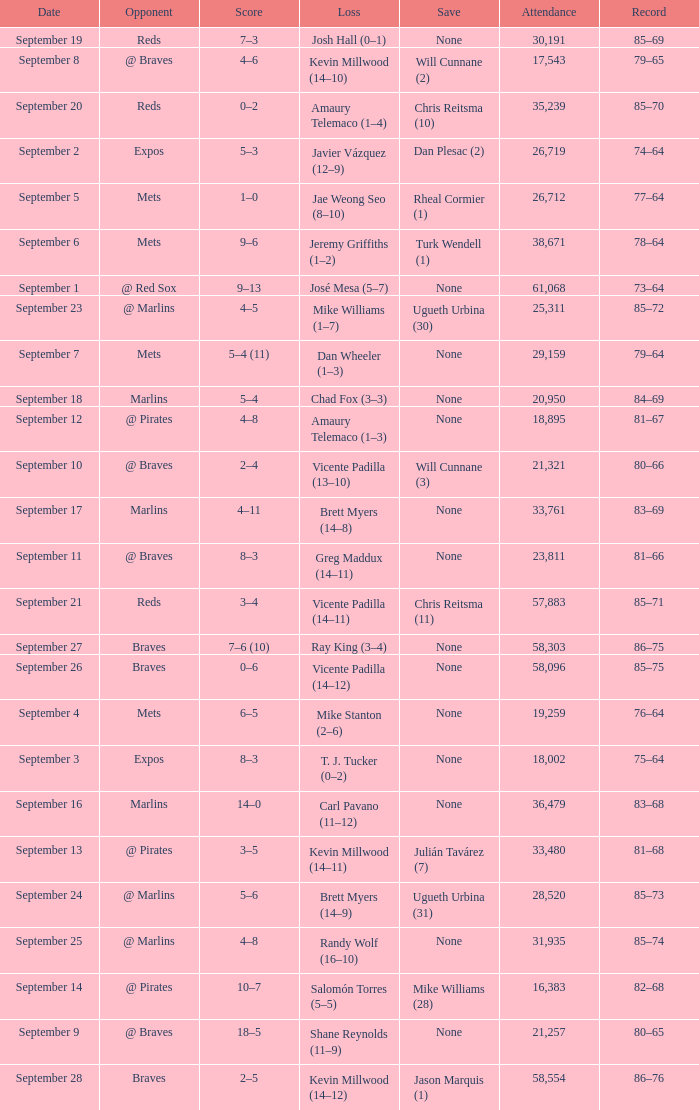What was the score of the game that had a loss of Chad Fox (3–3)? 5–4. 